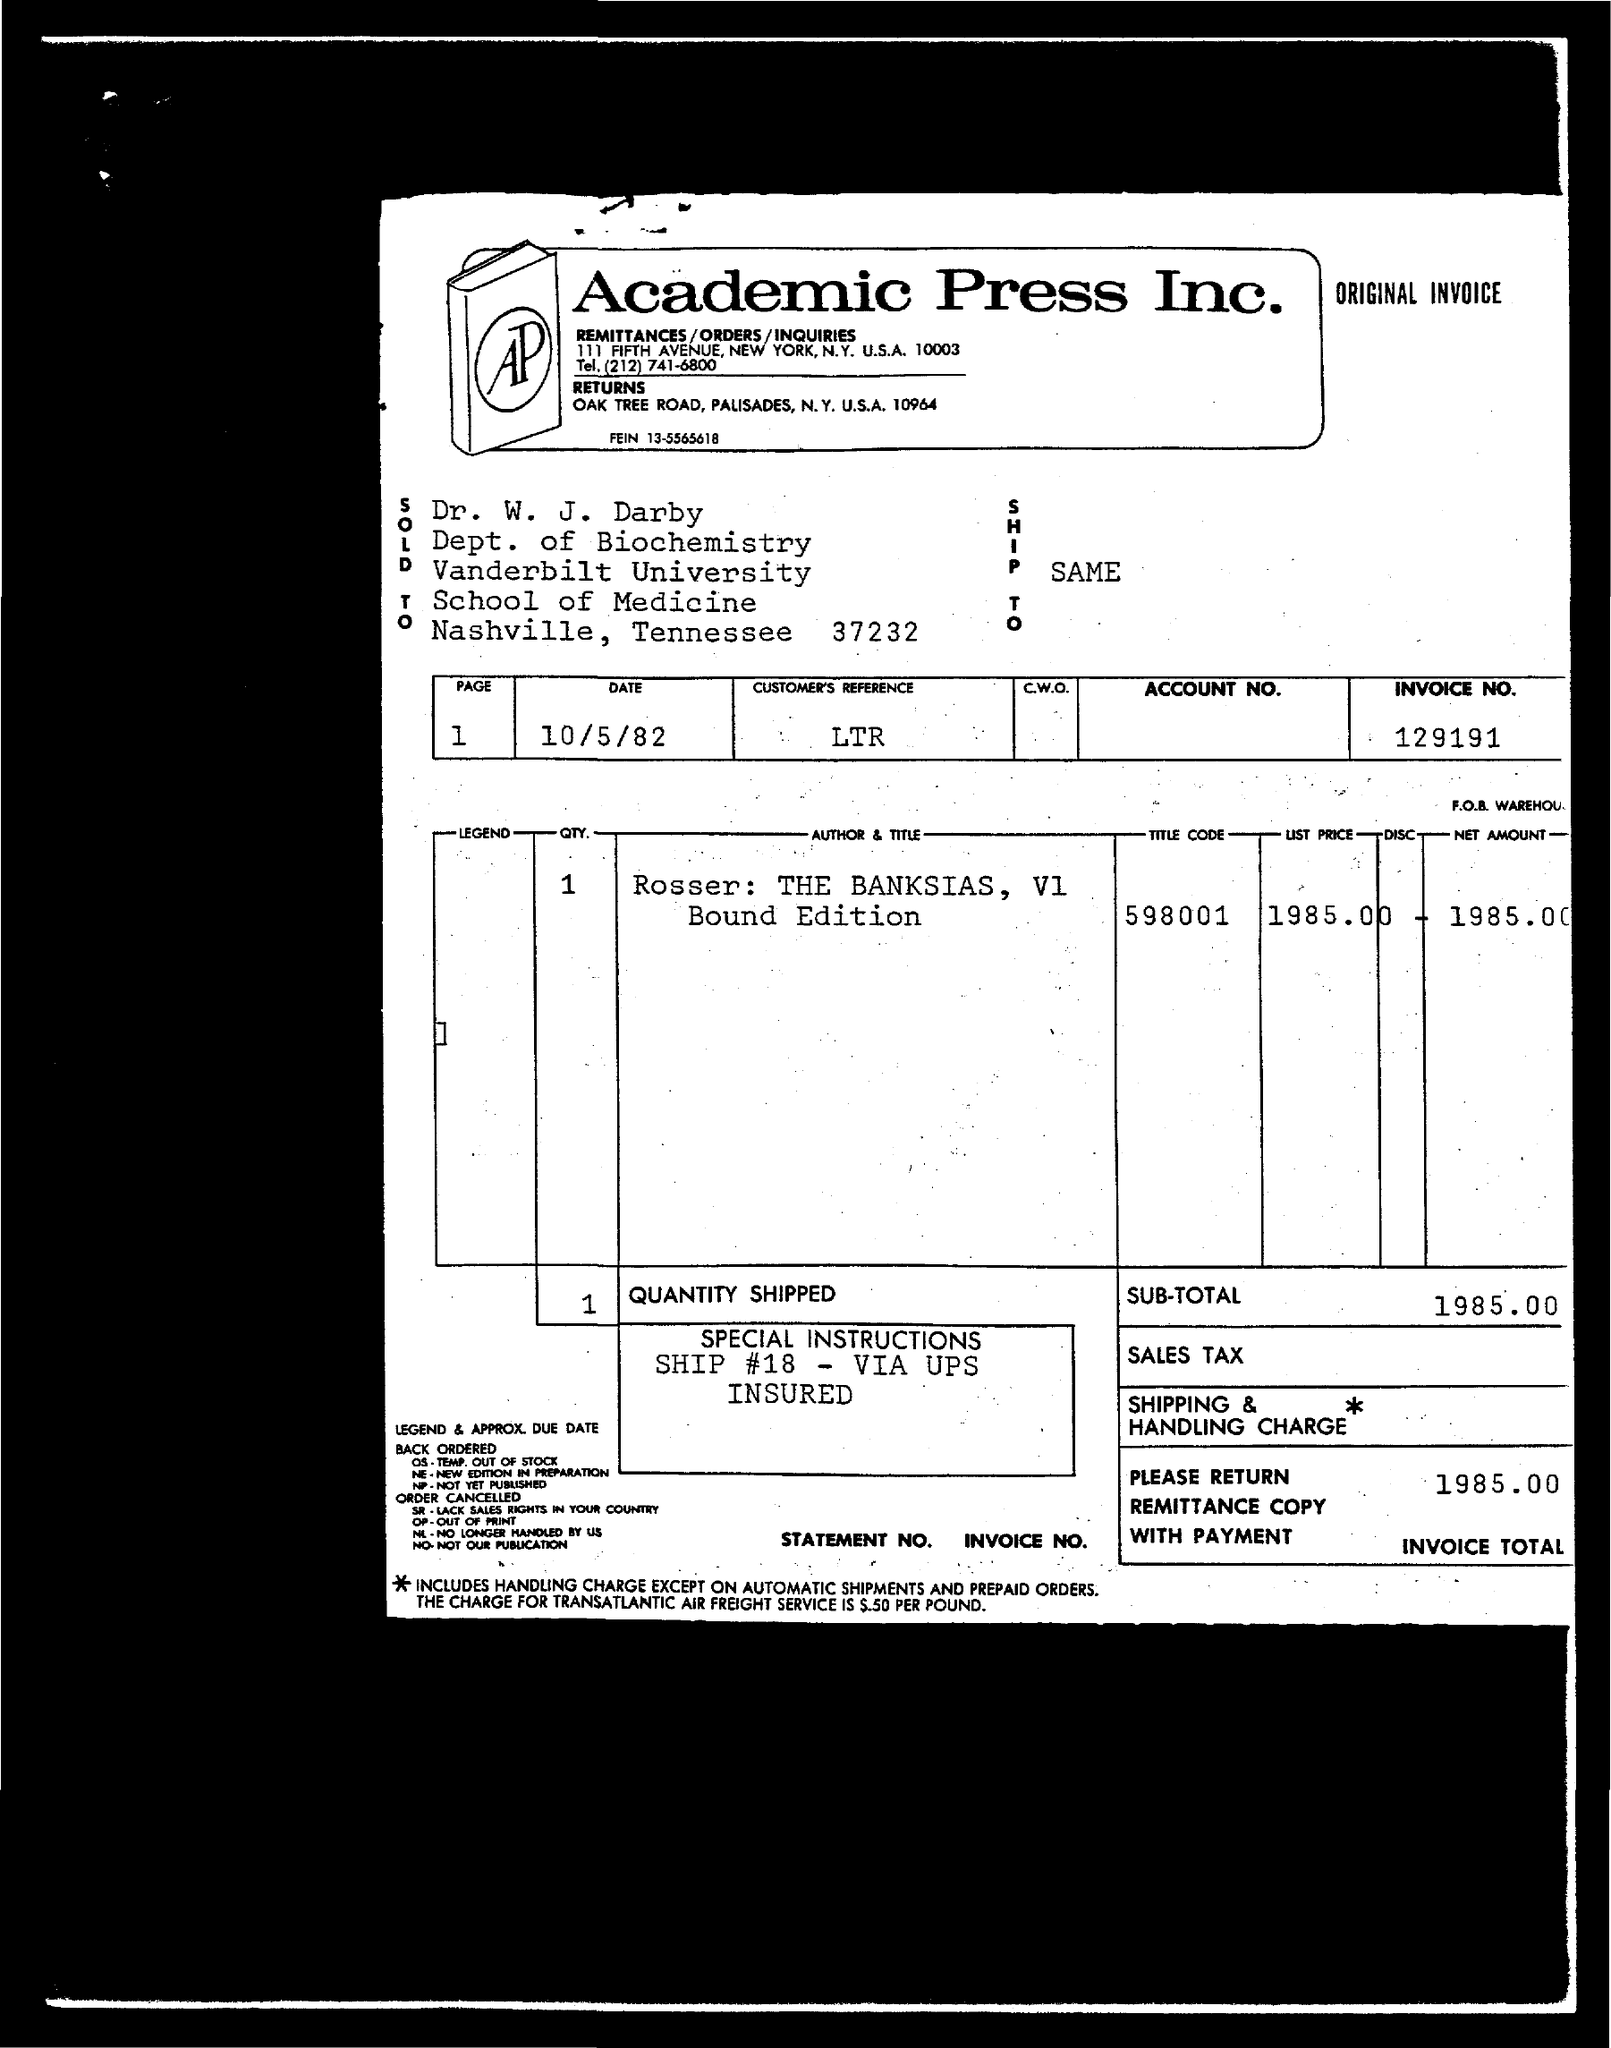Highlight a few significant elements in this photo. The invoice total given in the document is 1985.00. The customer's reference mentioned on the invoice is LTR. The list price on the invoice is 1985.00. The date mentioned on the invoice is October 5, 1982. The title code mentioned in the invoice is 598001. 